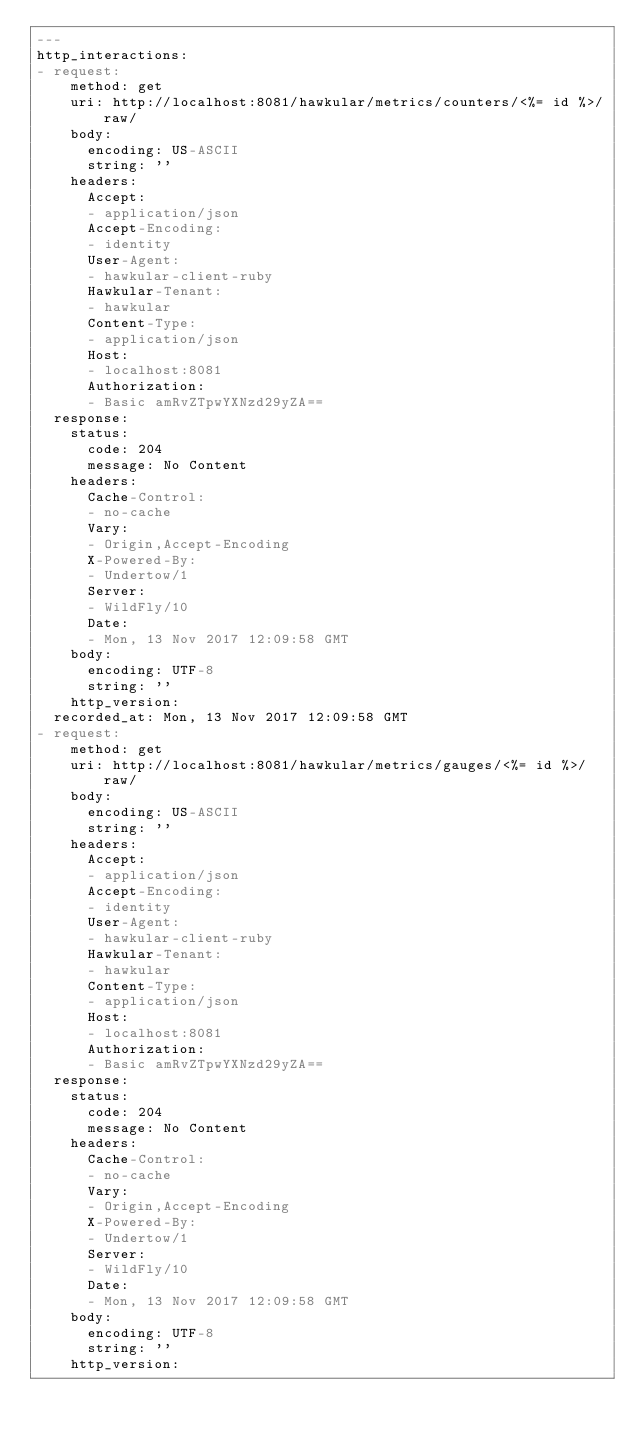Convert code to text. <code><loc_0><loc_0><loc_500><loc_500><_YAML_>---
http_interactions:
- request:
    method: get
    uri: http://localhost:8081/hawkular/metrics/counters/<%= id %>/raw/
    body:
      encoding: US-ASCII
      string: ''
    headers:
      Accept:
      - application/json
      Accept-Encoding:
      - identity
      User-Agent:
      - hawkular-client-ruby
      Hawkular-Tenant:
      - hawkular
      Content-Type:
      - application/json
      Host:
      - localhost:8081
      Authorization:
      - Basic amRvZTpwYXNzd29yZA==
  response:
    status:
      code: 204
      message: No Content
    headers:
      Cache-Control:
      - no-cache
      Vary:
      - Origin,Accept-Encoding
      X-Powered-By:
      - Undertow/1
      Server:
      - WildFly/10
      Date:
      - Mon, 13 Nov 2017 12:09:58 GMT
    body:
      encoding: UTF-8
      string: ''
    http_version: 
  recorded_at: Mon, 13 Nov 2017 12:09:58 GMT
- request:
    method: get
    uri: http://localhost:8081/hawkular/metrics/gauges/<%= id %>/raw/
    body:
      encoding: US-ASCII
      string: ''
    headers:
      Accept:
      - application/json
      Accept-Encoding:
      - identity
      User-Agent:
      - hawkular-client-ruby
      Hawkular-Tenant:
      - hawkular
      Content-Type:
      - application/json
      Host:
      - localhost:8081
      Authorization:
      - Basic amRvZTpwYXNzd29yZA==
  response:
    status:
      code: 204
      message: No Content
    headers:
      Cache-Control:
      - no-cache
      Vary:
      - Origin,Accept-Encoding
      X-Powered-By:
      - Undertow/1
      Server:
      - WildFly/10
      Date:
      - Mon, 13 Nov 2017 12:09:58 GMT
    body:
      encoding: UTF-8
      string: ''
    http_version: </code> 